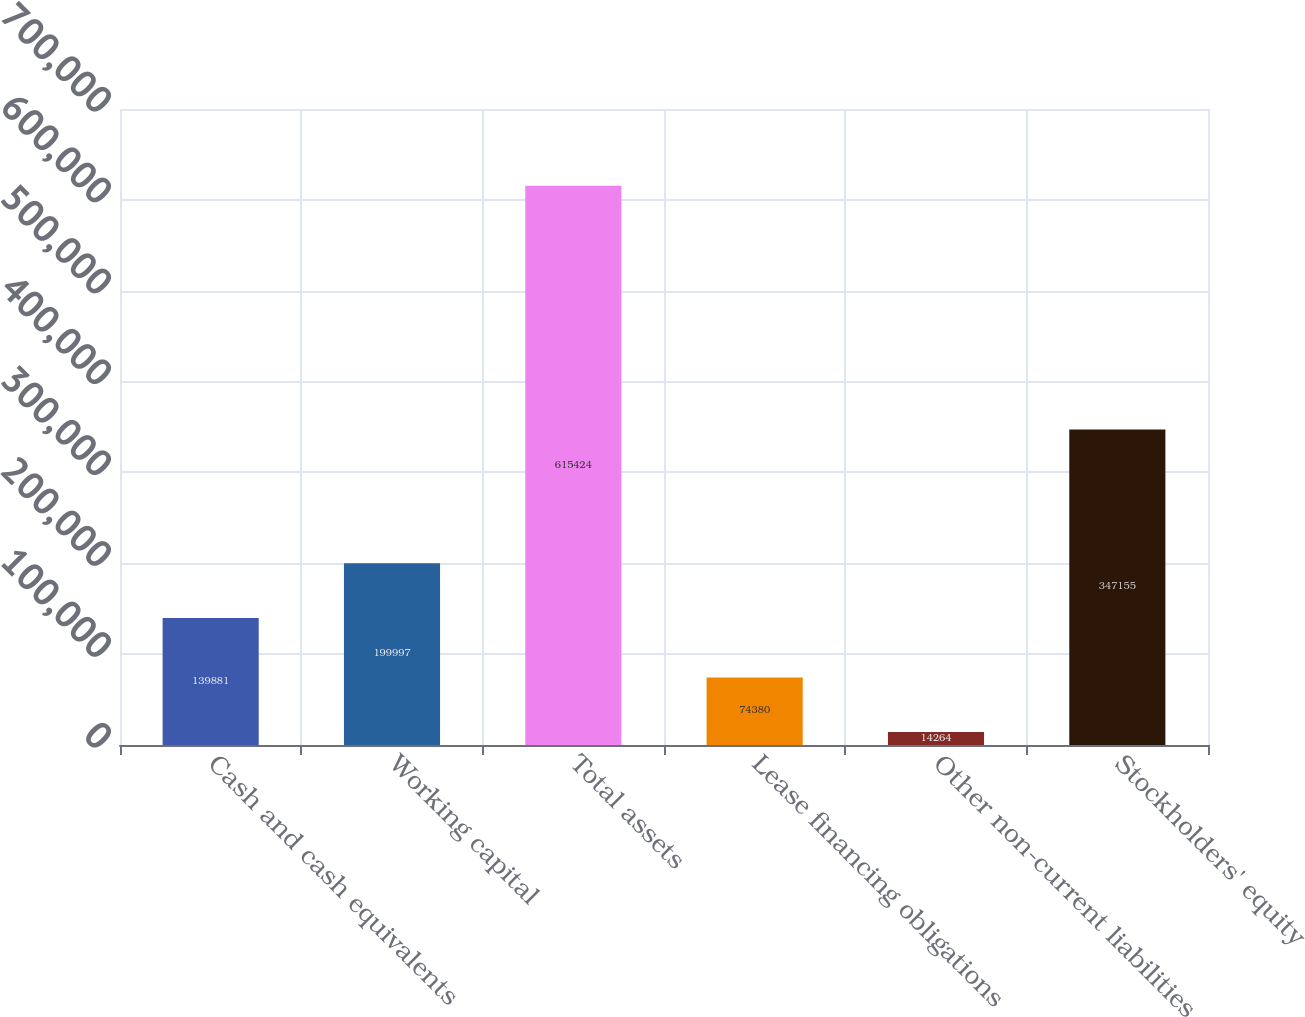<chart> <loc_0><loc_0><loc_500><loc_500><bar_chart><fcel>Cash and cash equivalents<fcel>Working capital<fcel>Total assets<fcel>Lease financing obligations<fcel>Other non-current liabilities<fcel>Stockholders' equity<nl><fcel>139881<fcel>199997<fcel>615424<fcel>74380<fcel>14264<fcel>347155<nl></chart> 